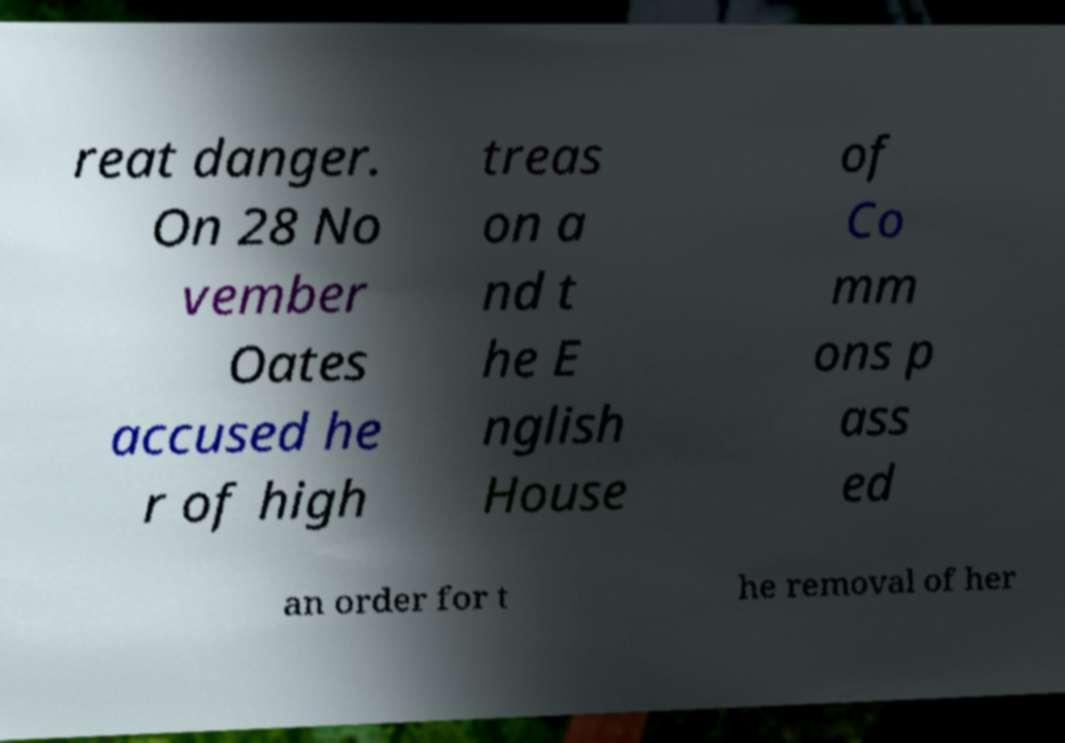I need the written content from this picture converted into text. Can you do that? reat danger. On 28 No vember Oates accused he r of high treas on a nd t he E nglish House of Co mm ons p ass ed an order for t he removal of her 